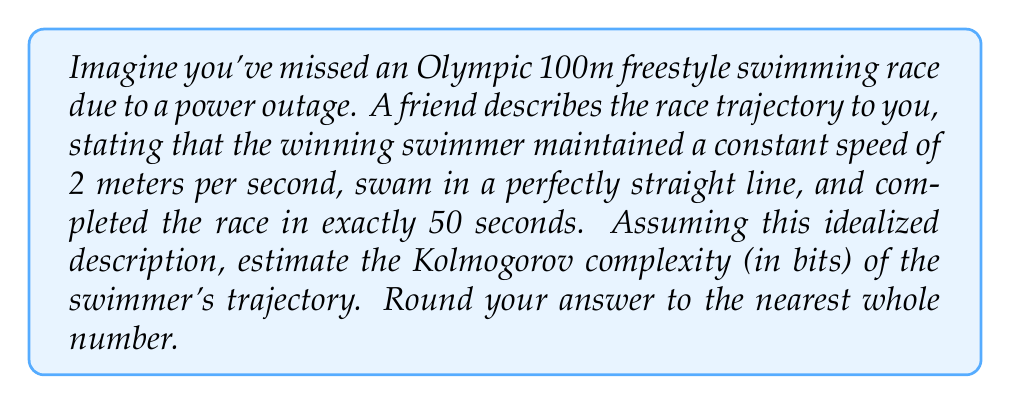Help me with this question. To estimate the Kolmogorov complexity of the swimmer's trajectory, we need to consider the minimum amount of information required to describe the path:

1. The swimming pool is a standard 50m length for Olympic competitions.

2. The trajectory is described as a straight line at constant speed.

3. To encode this information, we need:
   a) Starting position (assumed to be at one end of the pool): 0 bits
   b) Direction (assumed to be along the length of the pool): 0 bits
   c) Speed: This requires more precision
   d) Duration: This also requires precision

4. For the speed:
   - We're given 2 m/s, which can be represented as a rational number 2/1
   - To encode a rational number, we need to encode two integers
   - Each integer can be encoded in roughly $\log_2(n)$ bits, where n is the integer
   - For 2, we need $\log_2(2) \approx 1$ bit
   - For 1, we need $\log_2(1) = 0$ bits
   - Total for speed: 1 bit

5. For the duration:
   - 50 seconds can be encoded as an integer
   - This requires $\log_2(50) \approx 5.64$ bits

6. We also need a few bits to encode the program that interprets this data and generates the trajectory. Let's estimate this at about 20 bits for a very simple program.

7. Total Kolmogorov complexity:
   $$ K \approx 1 + 5.64 + 20 = 26.64 \text{ bits} $$

8. Rounding to the nearest whole number: 27 bits

This estimate assumes a very simple model and minimal encoding scheme. In reality, the Kolmogorov complexity might be slightly higher due to additional factors not considered in this idealized scenario.
Answer: 27 bits 